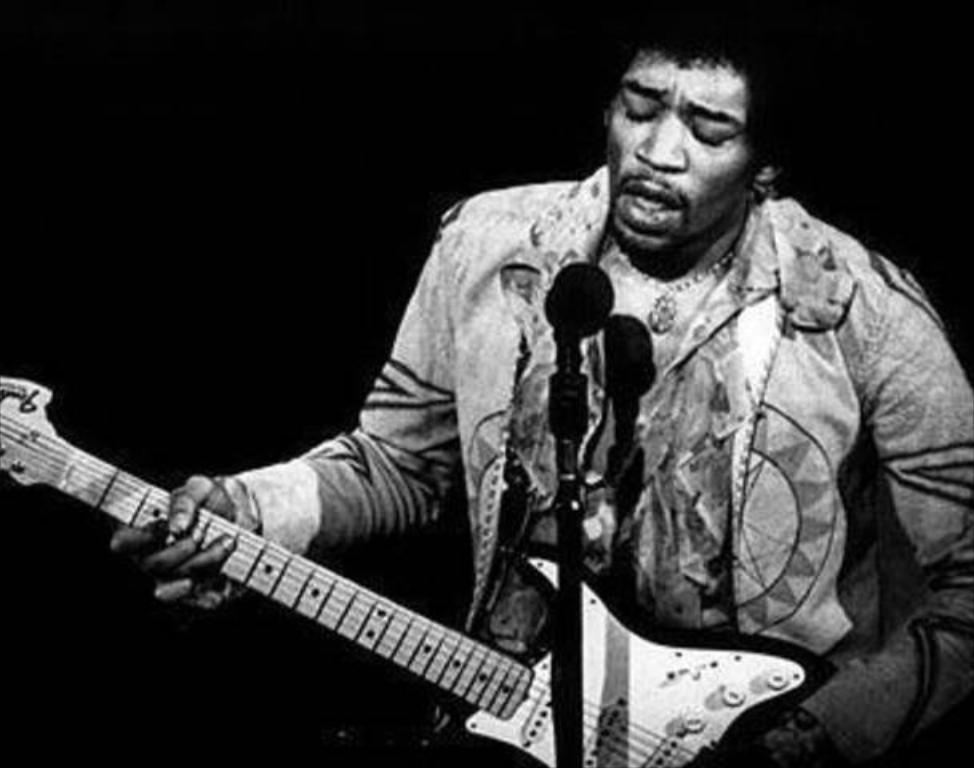What is the man in the image doing? The man is playing the guitar and singing on a microphone. What object is the man holding in the image? The man is holding a guitar. What can be inferred about the man's activity in the image? The man is likely performing music, given that he is playing the guitar and singing on a microphone. What is the color of the background in the image? The background of the image is dark. How much sugar is in the man's coffee in the image? There is no coffee or sugar present in the image; the man is playing the guitar and singing on a microphone. What type of error can be seen in the image? There is no error present in the image; the man is performing music with a guitar and microphone. 